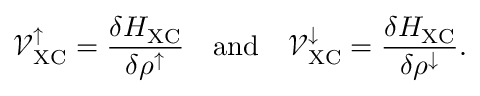<formula> <loc_0><loc_0><loc_500><loc_500>\mathcal { V } _ { X C } ^ { \uparrow } = \frac { \delta H _ { X C } } { \delta \rho ^ { \uparrow } } \quad a n d \quad \mathcal { V } _ { X C } ^ { \downarrow } = \frac { \delta H _ { X C } } { \delta \rho ^ { \downarrow } } .</formula> 